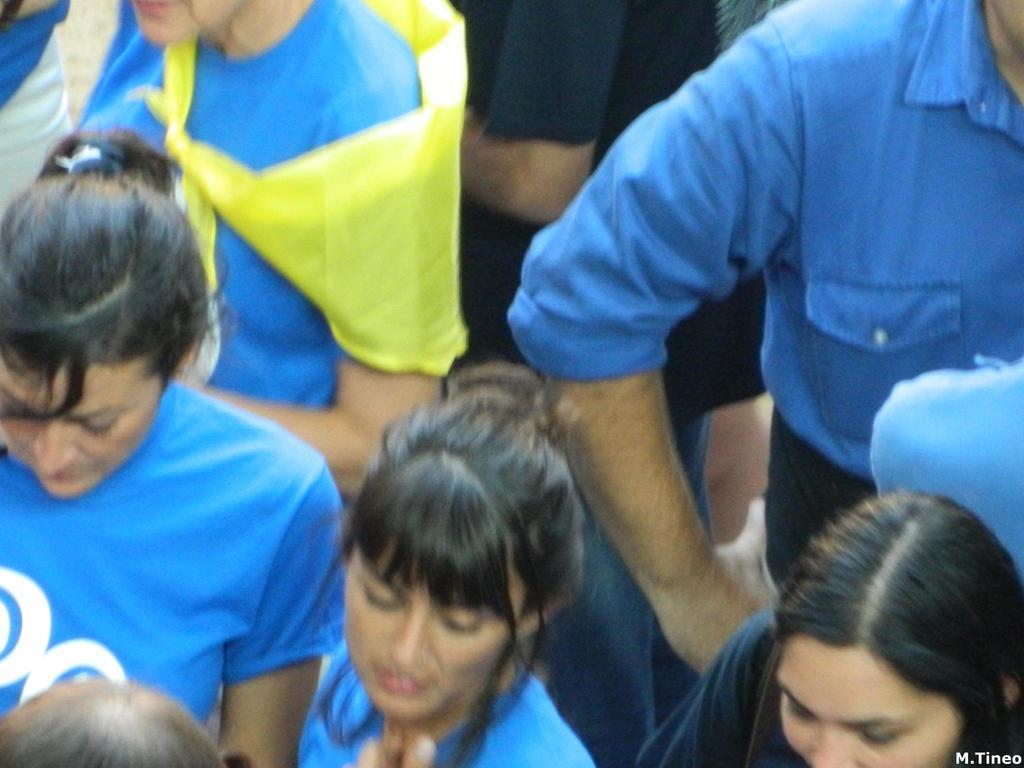In one or two sentences, can you explain what this image depicts? In this image we can see these people wearing blue dresses and this person is wearing black T-shirt. Here we can see the watermark on the bottom right side of the image. 